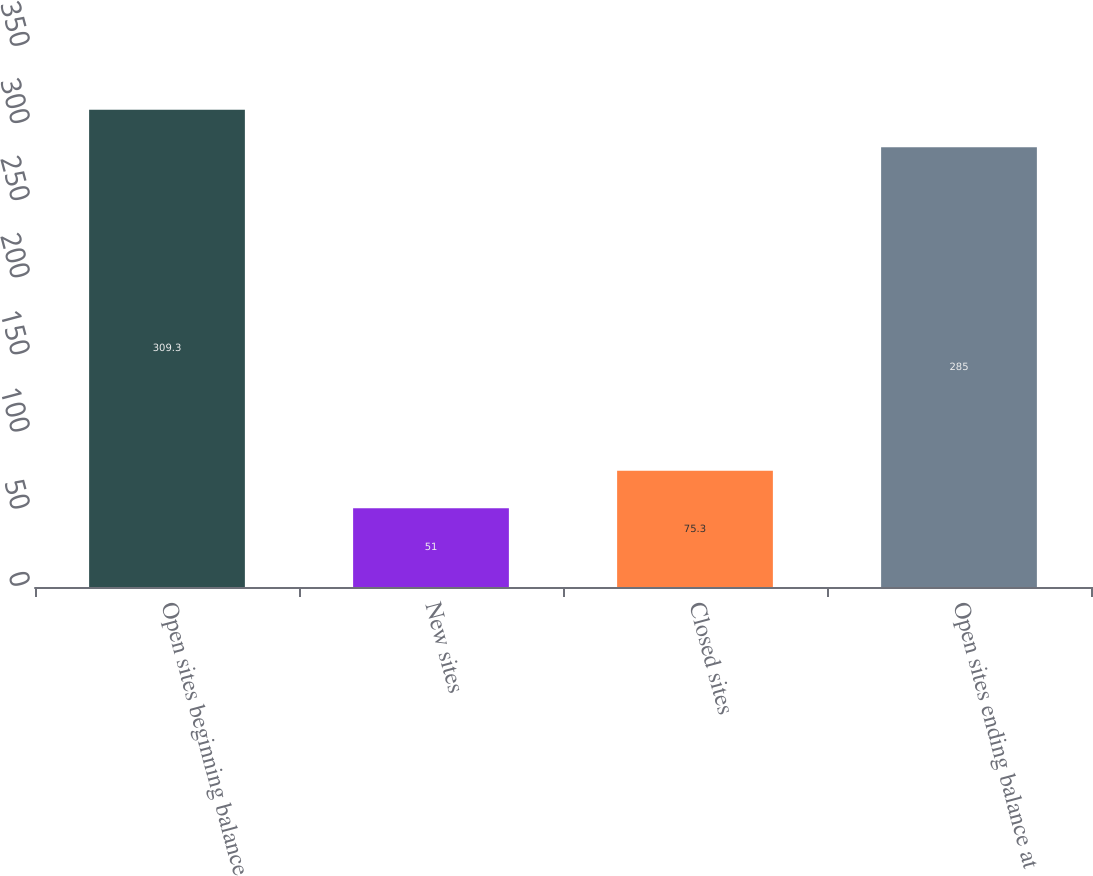Convert chart. <chart><loc_0><loc_0><loc_500><loc_500><bar_chart><fcel>Open sites beginning balance<fcel>New sites<fcel>Closed sites<fcel>Open sites ending balance at<nl><fcel>309.3<fcel>51<fcel>75.3<fcel>285<nl></chart> 